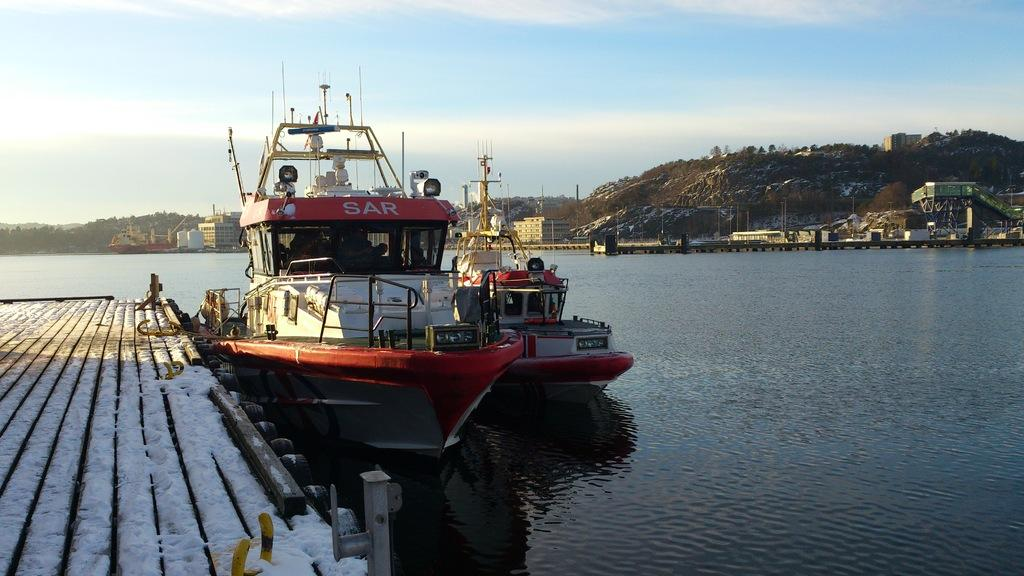<image>
Offer a succinct explanation of the picture presented. A red and white boat is docked with teh text sar on the top red side of it. 